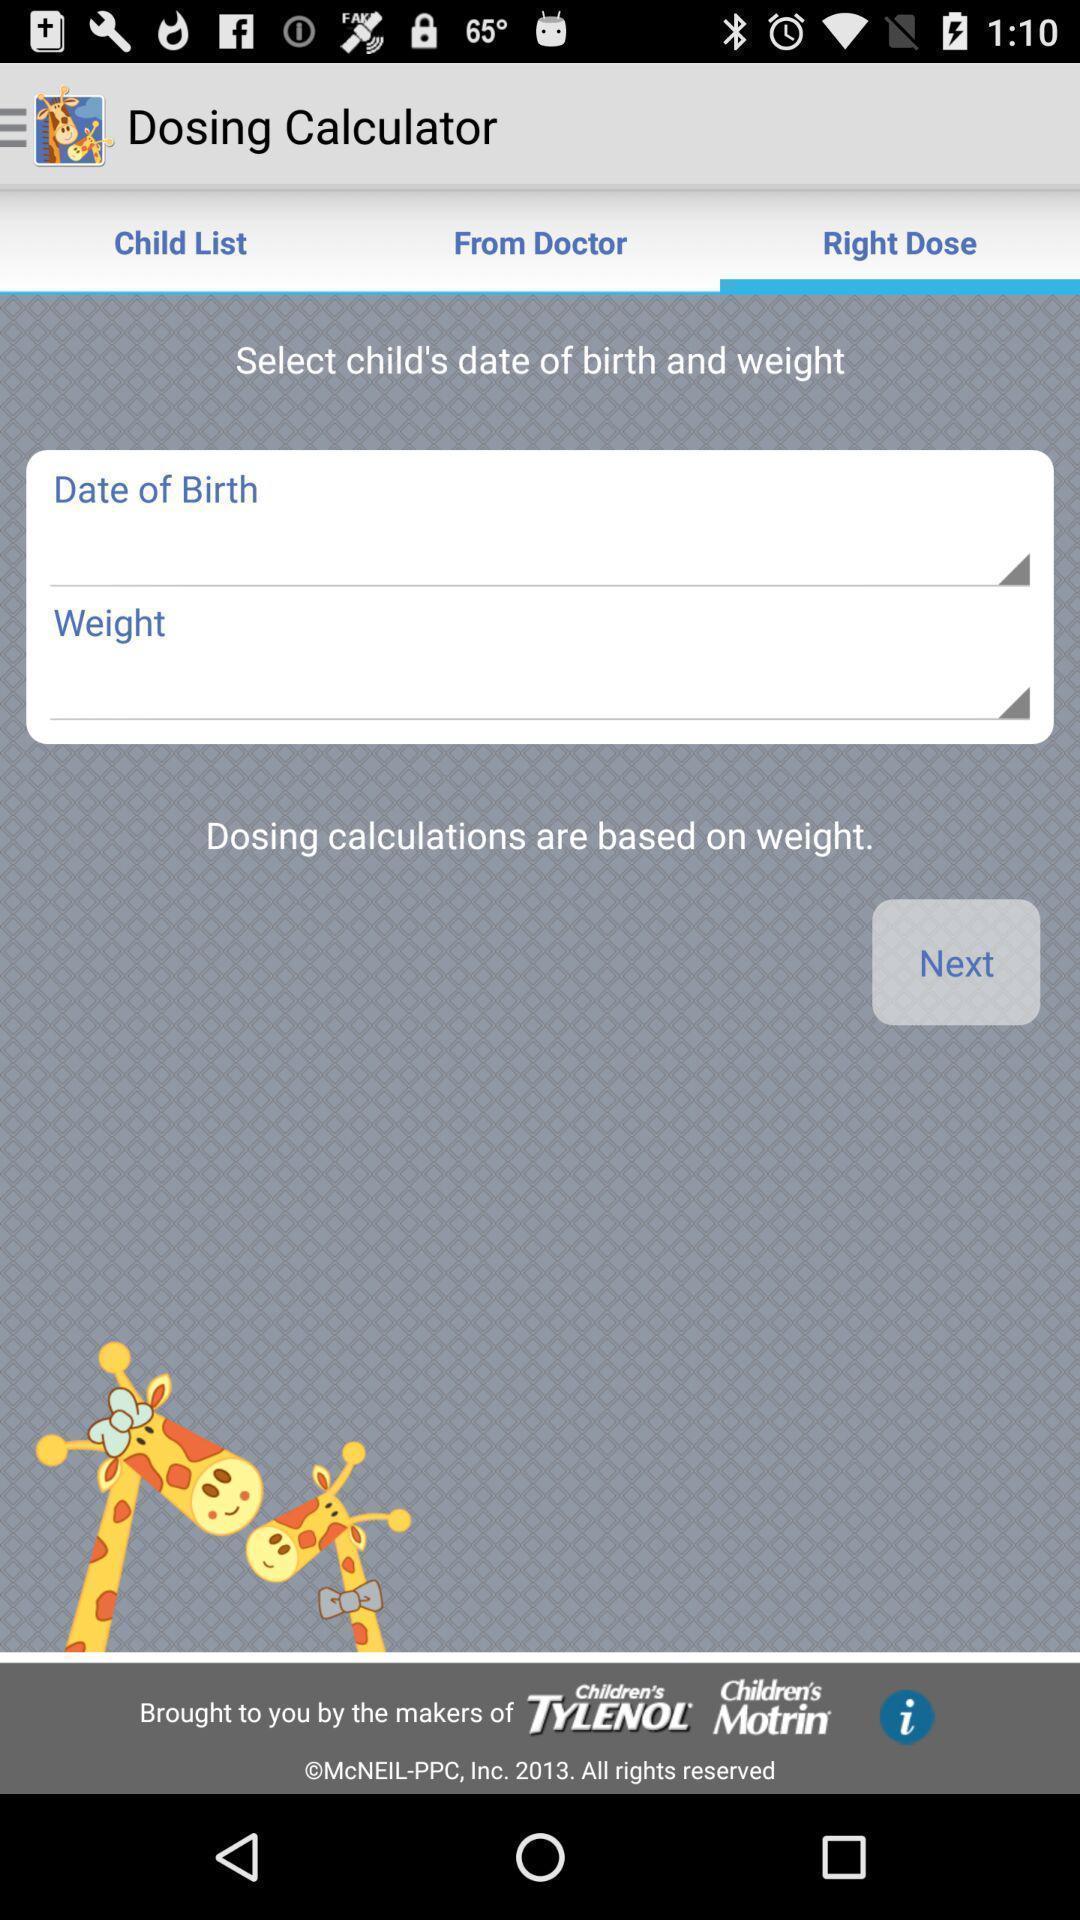Describe the visual elements of this screenshot. Page with details entry in health care application. 